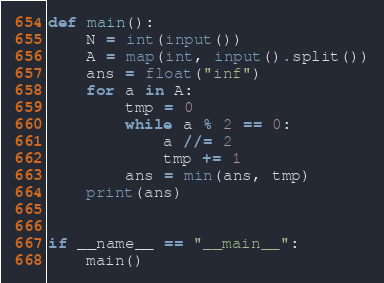Convert code to text. <code><loc_0><loc_0><loc_500><loc_500><_Python_>def main():
    N = int(input())
    A = map(int, input().split())
    ans = float("inf")
    for a in A:
        tmp = 0
        while a % 2 == 0:
            a //= 2
            tmp += 1
        ans = min(ans, tmp)
    print(ans)


if __name__ == "__main__":
    main()
</code> 